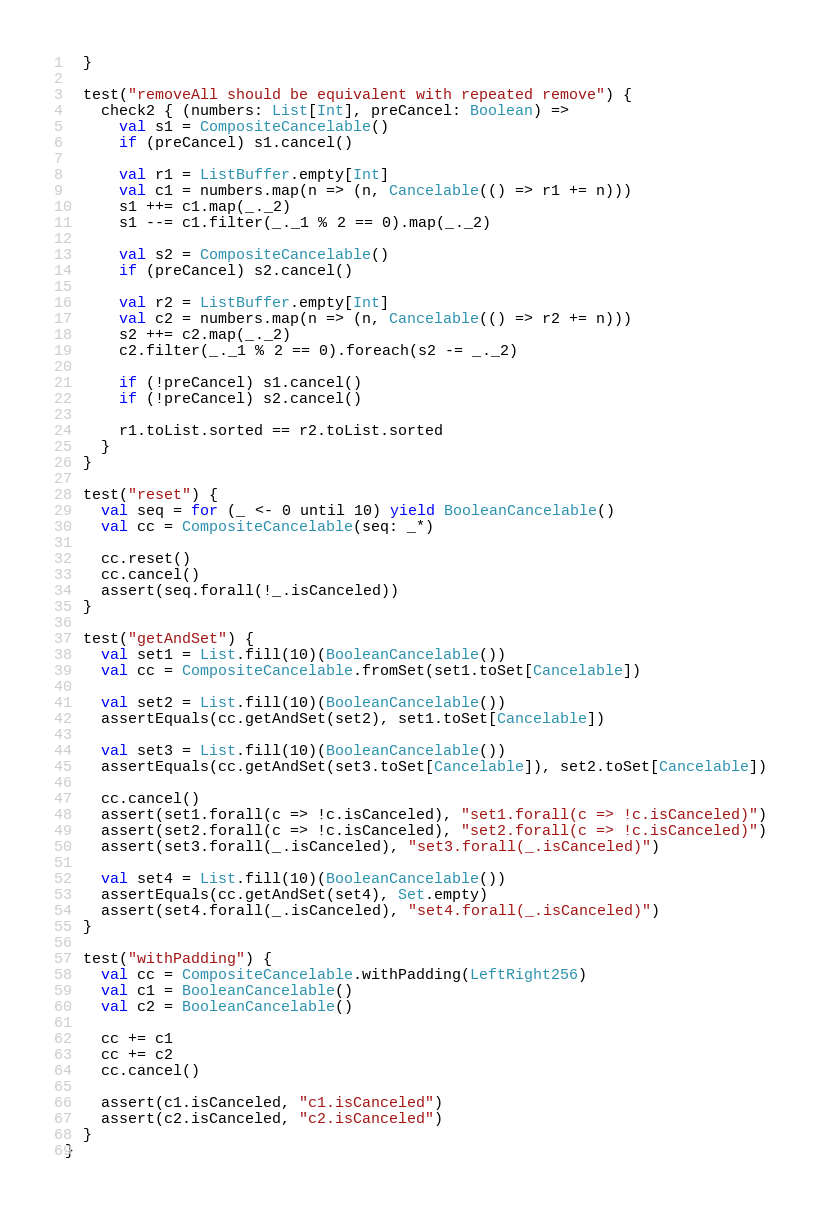Convert code to text. <code><loc_0><loc_0><loc_500><loc_500><_Scala_>  }

  test("removeAll should be equivalent with repeated remove") {
    check2 { (numbers: List[Int], preCancel: Boolean) =>
      val s1 = CompositeCancelable()
      if (preCancel) s1.cancel()

      val r1 = ListBuffer.empty[Int]
      val c1 = numbers.map(n => (n, Cancelable(() => r1 += n)))
      s1 ++= c1.map(_._2)
      s1 --= c1.filter(_._1 % 2 == 0).map(_._2)

      val s2 = CompositeCancelable()
      if (preCancel) s2.cancel()

      val r2 = ListBuffer.empty[Int]
      val c2 = numbers.map(n => (n, Cancelable(() => r2 += n)))
      s2 ++= c2.map(_._2)
      c2.filter(_._1 % 2 == 0).foreach(s2 -= _._2)

      if (!preCancel) s1.cancel()
      if (!preCancel) s2.cancel()

      r1.toList.sorted == r2.toList.sorted
    }
  }

  test("reset") {
    val seq = for (_ <- 0 until 10) yield BooleanCancelable()
    val cc = CompositeCancelable(seq: _*)

    cc.reset()
    cc.cancel()
    assert(seq.forall(!_.isCanceled))
  }

  test("getAndSet") {
    val set1 = List.fill(10)(BooleanCancelable())
    val cc = CompositeCancelable.fromSet(set1.toSet[Cancelable])

    val set2 = List.fill(10)(BooleanCancelable())
    assertEquals(cc.getAndSet(set2), set1.toSet[Cancelable])

    val set3 = List.fill(10)(BooleanCancelable())
    assertEquals(cc.getAndSet(set3.toSet[Cancelable]), set2.toSet[Cancelable])

    cc.cancel()
    assert(set1.forall(c => !c.isCanceled), "set1.forall(c => !c.isCanceled)")
    assert(set2.forall(c => !c.isCanceled), "set2.forall(c => !c.isCanceled)")
    assert(set3.forall(_.isCanceled), "set3.forall(_.isCanceled)")

    val set4 = List.fill(10)(BooleanCancelable())
    assertEquals(cc.getAndSet(set4), Set.empty)
    assert(set4.forall(_.isCanceled), "set4.forall(_.isCanceled)")
  }

  test("withPadding") {
    val cc = CompositeCancelable.withPadding(LeftRight256)
    val c1 = BooleanCancelable()
    val c2 = BooleanCancelable()

    cc += c1
    cc += c2
    cc.cancel()

    assert(c1.isCanceled, "c1.isCanceled")
    assert(c2.isCanceled, "c2.isCanceled")
  }
}
</code> 